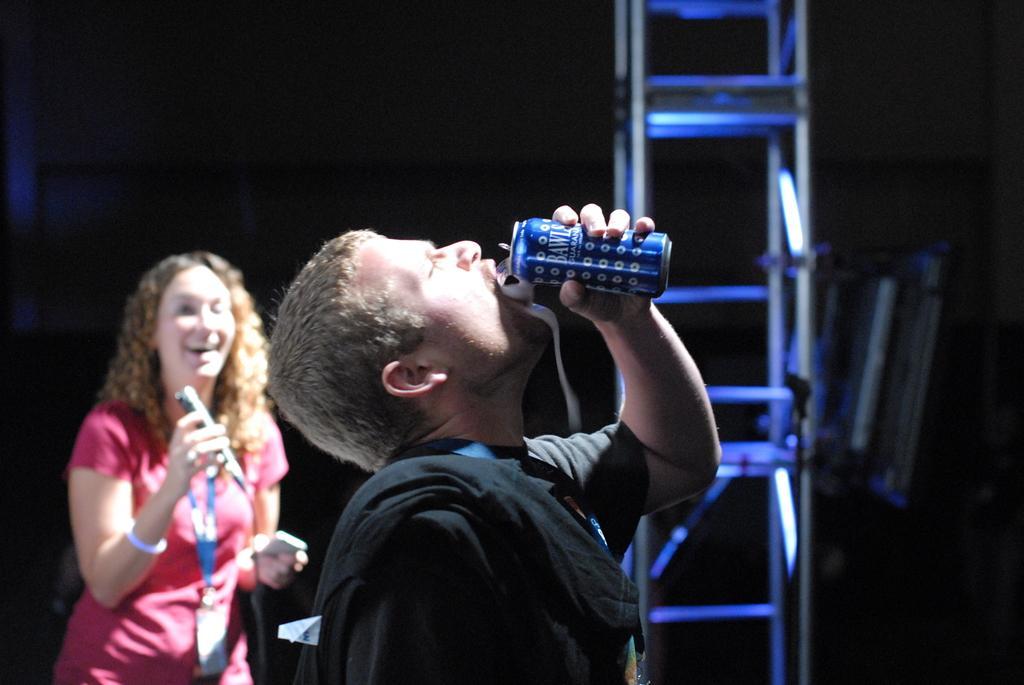Please provide a concise description of this image. In this image I can see two people. Among them one person is drinking something and another one is holding the mic. 